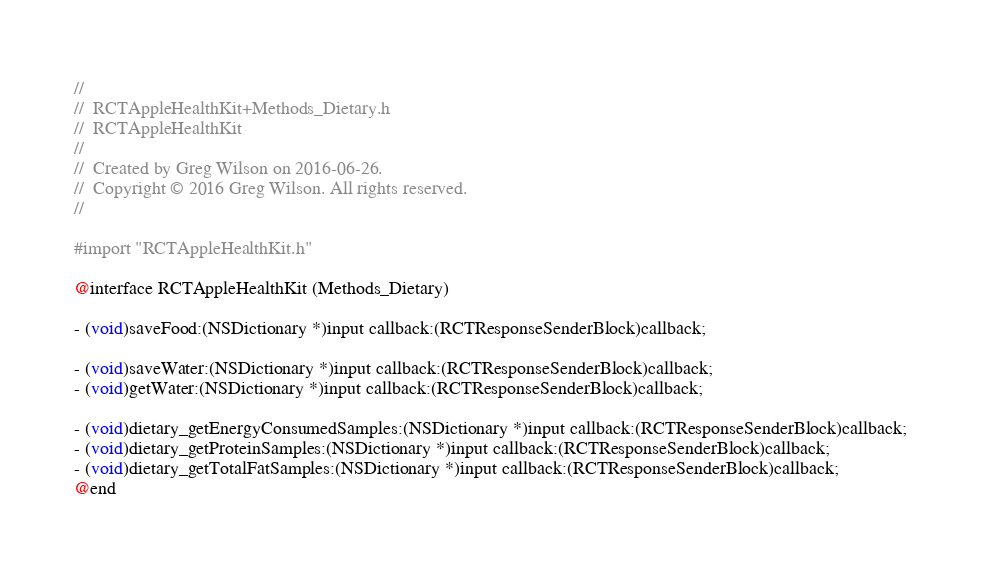Convert code to text. <code><loc_0><loc_0><loc_500><loc_500><_C_>//
//  RCTAppleHealthKit+Methods_Dietary.h
//  RCTAppleHealthKit
//
//  Created by Greg Wilson on 2016-06-26.
//  Copyright © 2016 Greg Wilson. All rights reserved.
//

#import "RCTAppleHealthKit.h"

@interface RCTAppleHealthKit (Methods_Dietary)

- (void)saveFood:(NSDictionary *)input callback:(RCTResponseSenderBlock)callback;

- (void)saveWater:(NSDictionary *)input callback:(RCTResponseSenderBlock)callback;
- (void)getWater:(NSDictionary *)input callback:(RCTResponseSenderBlock)callback;

- (void)dietary_getEnergyConsumedSamples:(NSDictionary *)input callback:(RCTResponseSenderBlock)callback;
- (void)dietary_getProteinSamples:(NSDictionary *)input callback:(RCTResponseSenderBlock)callback;
- (void)dietary_getTotalFatSamples:(NSDictionary *)input callback:(RCTResponseSenderBlock)callback;
@end
</code> 